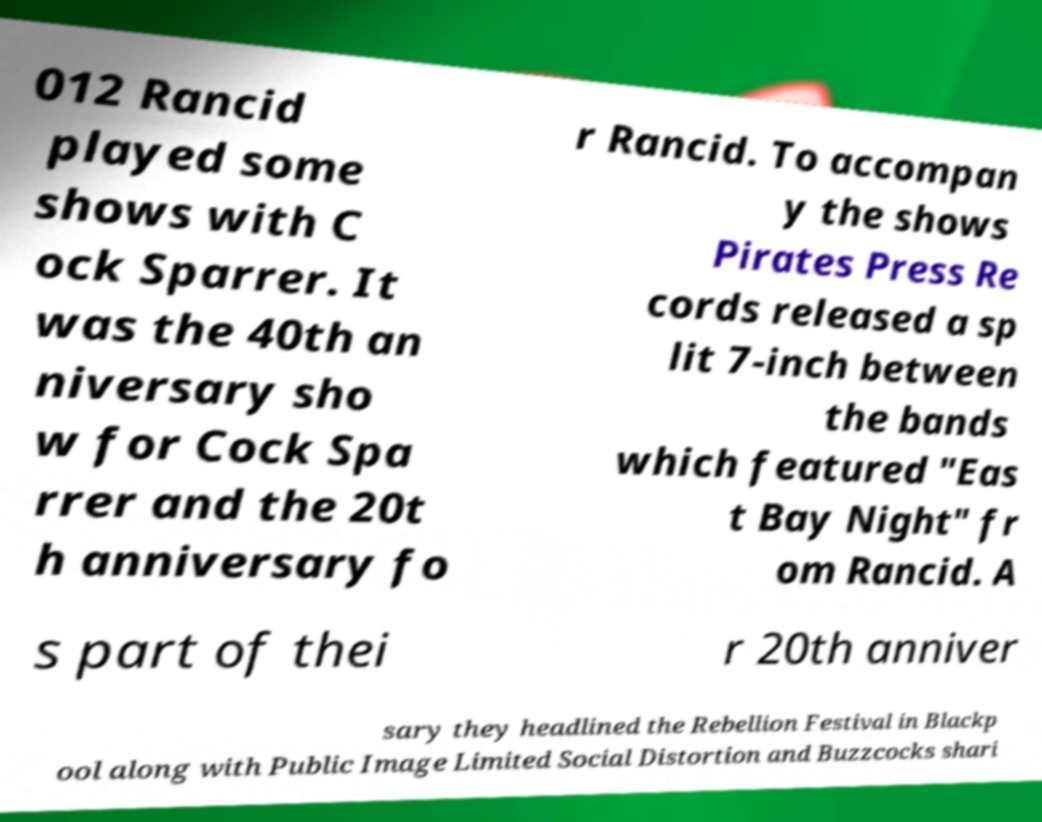What messages or text are displayed in this image? I need them in a readable, typed format. 012 Rancid played some shows with C ock Sparrer. It was the 40th an niversary sho w for Cock Spa rrer and the 20t h anniversary fo r Rancid. To accompan y the shows Pirates Press Re cords released a sp lit 7-inch between the bands which featured "Eas t Bay Night" fr om Rancid. A s part of thei r 20th anniver sary they headlined the Rebellion Festival in Blackp ool along with Public Image Limited Social Distortion and Buzzcocks shari 